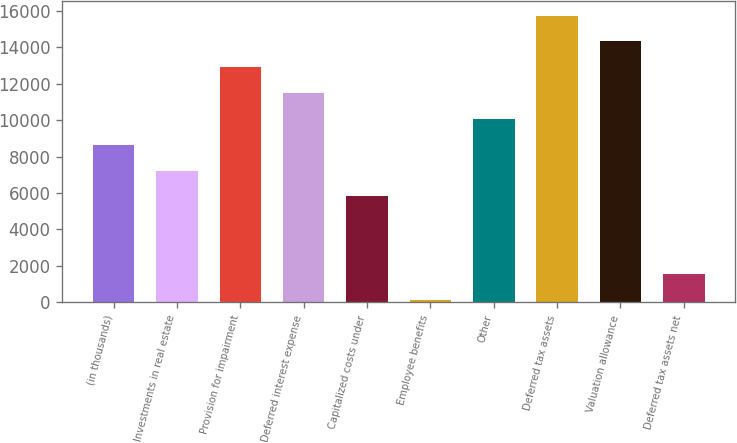Convert chart to OTSL. <chart><loc_0><loc_0><loc_500><loc_500><bar_chart><fcel>(in thousands)<fcel>Investments in real estate<fcel>Provision for impairment<fcel>Deferred interest expense<fcel>Capitalized costs under<fcel>Employee benefits<fcel>Other<fcel>Deferred tax assets<fcel>Valuation allowance<fcel>Deferred tax assets net<nl><fcel>8647<fcel>7230.5<fcel>12896.5<fcel>11480<fcel>5814<fcel>148<fcel>10063.5<fcel>15729.5<fcel>14313<fcel>1564.5<nl></chart> 